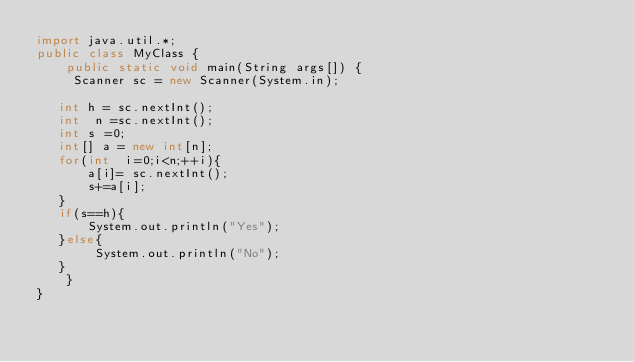Convert code to text. <code><loc_0><loc_0><loc_500><loc_500><_Java_>import java.util.*;
public class MyClass {
    public static void main(String args[]) {
     Scanner sc = new Scanner(System.in);
     
   int h = sc.nextInt();
   int  n =sc.nextInt();
   int s =0;
   int[] a = new int[n];
   for(int  i=0;i<n;++i){
       a[i]= sc.nextInt();
       s+=a[i];
   }
   if(s==h){
       System.out.println("Yes");
   }else{
        System.out.println("No");
   }
    }
}</code> 